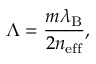<formula> <loc_0><loc_0><loc_500><loc_500>\Lambda = \frac { m \lambda _ { B } } { 2 n _ { e f f } } ,</formula> 